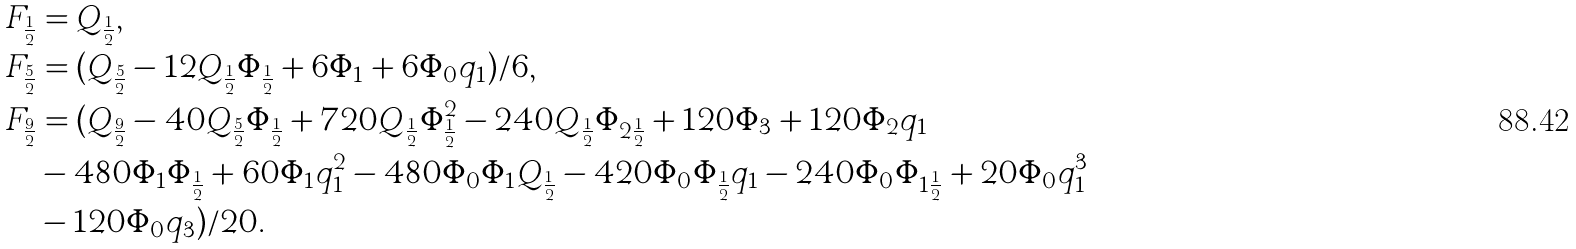Convert formula to latex. <formula><loc_0><loc_0><loc_500><loc_500>F _ { \frac { 1 } { 2 } } & = Q _ { \frac { 1 } { 2 } } , \\ F _ { \frac { 5 } { 2 } } & = ( Q _ { \frac { 5 } { 2 } } - 1 2 Q _ { \frac { 1 } { 2 } } \Phi _ { \frac { 1 } { 2 } } + 6 \Phi _ { 1 } + 6 \Phi _ { 0 } q _ { 1 } ) / 6 , \\ F _ { \frac { 9 } { 2 } } & = ( Q _ { \frac { 9 } { 2 } } - 4 0 Q _ { \frac { 5 } { 2 } } \Phi _ { \frac { 1 } { 2 } } + 7 2 0 Q _ { \frac { 1 } { 2 } } \Phi _ { \frac { 1 } { 2 } } ^ { 2 } - 2 4 0 Q _ { \frac { 1 } { 2 } } \Phi _ { 2 \frac { 1 } { 2 } } + 1 2 0 \Phi _ { 3 } + 1 2 0 \Phi _ { 2 } q _ { 1 } \\ & - 4 8 0 \Phi _ { 1 } \Phi _ { \frac { 1 } { 2 } } + 6 0 \Phi _ { 1 } q _ { 1 } ^ { 2 } - 4 8 0 \Phi _ { 0 } \Phi _ { 1 } Q _ { \frac { 1 } { 2 } } - 4 2 0 \Phi _ { 0 } \Phi _ { \frac { 1 } { 2 } } q _ { 1 } - 2 4 0 \Phi _ { 0 } \Phi _ { 1 \frac { 1 } { 2 } } + 2 0 \Phi _ { 0 } q _ { 1 } ^ { 3 } \\ & - 1 2 0 \Phi _ { 0 } q _ { 3 } ) / 2 0 .</formula> 